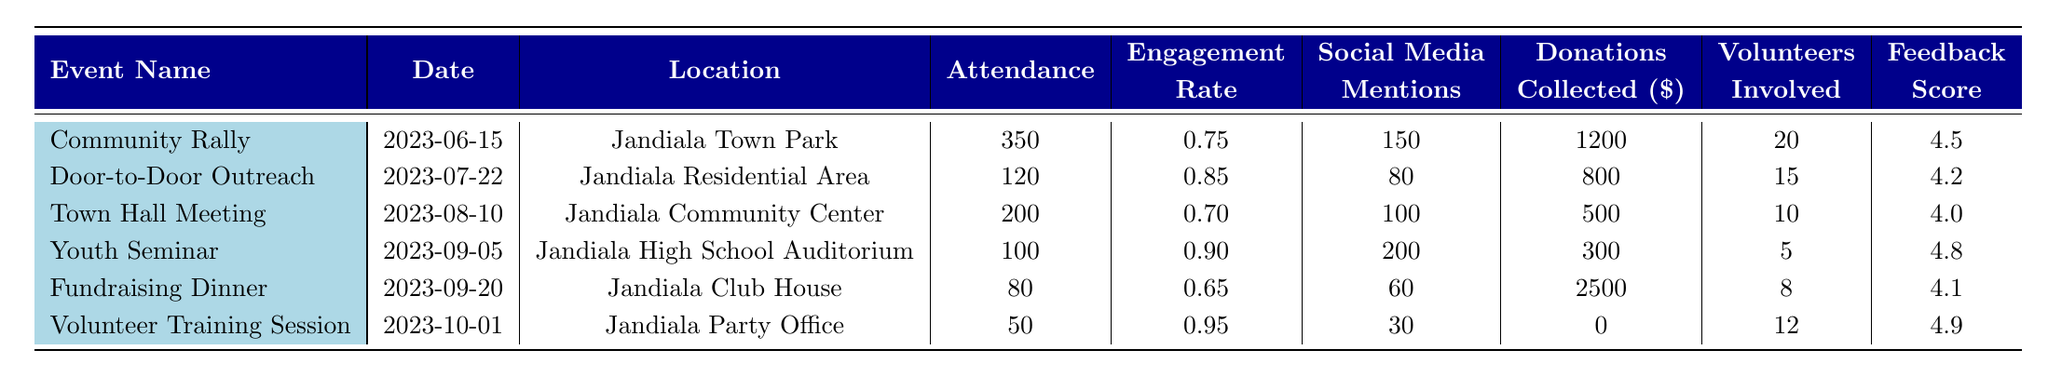What is the highest attendance recorded at a campaign event? The highest attendance shown in the table is 350 at the Community Rally event.
Answer: 350 What was the engagement rate for the Door-to-Door Outreach event? The engagement rate for the Door-to-Door Outreach event is 0.85, as specified in the table.
Answer: 0.85 How many donations were collected at the Fundraising Dinner? The table indicates that the Fundraising Dinner event collected $2,500 in donations.
Answer: 2500 What event had the lowest attendance? The Volunteer Training Session had the lowest attendance of 50, according to the table.
Answer: 50 What is the average feedback score across all campaign events? The feedback scores listed are 4.5, 4.2, 4.0, 4.8, 4.1, and 4.9. The sum is 27.5, and there are 6 events, so the average is 27.5 / 6 = 4.58.
Answer: 4.58 Was the engagement rate for the Youth Seminar higher than that of the Town Hall Meeting? The engagement rate for the Youth Seminar is 0.90, while the Town Hall Meeting's engagement rate is 0.70, confirming that the Youth Seminar had a higher engagement rate.
Answer: Yes What is the total amount of donations collected from all events? Adding donations from each event: 1200 + 800 + 500 + 300 + 2500 + 0 = 4300. Therefore, the total donations collected from all events is $4,300.
Answer: 4300 Which event involved the most volunteers? The Community Rally involved 20 volunteers, which is the highest compared to other events listed in the table.
Answer: 20 How many social media mentions were generated at the Youth Seminar? The table indicates that the Youth Seminar received 200 social media mentions.
Answer: 200 Which event had a feedback score of 4.9, and what was its engagement rate? The Volunteer Training Session had a feedback score of 4.9 and an engagement rate of 0.95 according to the data provided in the table.
Answer: Volunteer Training Session, 0.95 What is the difference in attendance between the Community Rally and the Fundraising Dinner? The attendance at the Community Rally is 350, while the Fundraising Dinner had 80. The difference is 350 - 80 = 270.
Answer: 270 